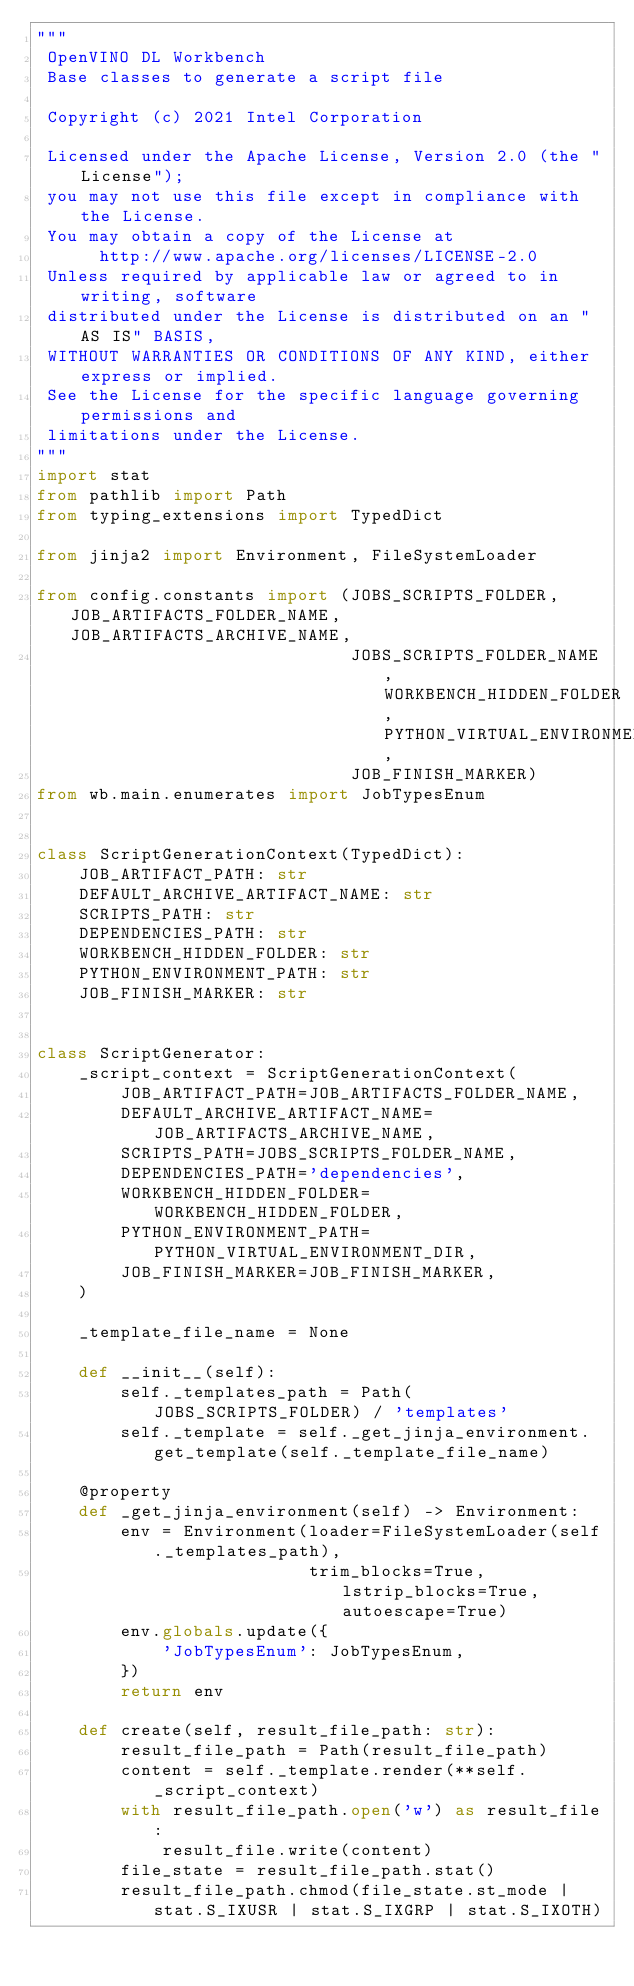<code> <loc_0><loc_0><loc_500><loc_500><_Python_>"""
 OpenVINO DL Workbench
 Base classes to generate a script file

 Copyright (c) 2021 Intel Corporation

 Licensed under the Apache License, Version 2.0 (the "License");
 you may not use this file except in compliance with the License.
 You may obtain a copy of the License at
      http://www.apache.org/licenses/LICENSE-2.0
 Unless required by applicable law or agreed to in writing, software
 distributed under the License is distributed on an "AS IS" BASIS,
 WITHOUT WARRANTIES OR CONDITIONS OF ANY KIND, either express or implied.
 See the License for the specific language governing permissions and
 limitations under the License.
"""
import stat
from pathlib import Path
from typing_extensions import TypedDict

from jinja2 import Environment, FileSystemLoader

from config.constants import (JOBS_SCRIPTS_FOLDER, JOB_ARTIFACTS_FOLDER_NAME, JOB_ARTIFACTS_ARCHIVE_NAME,
                              JOBS_SCRIPTS_FOLDER_NAME, WORKBENCH_HIDDEN_FOLDER, PYTHON_VIRTUAL_ENVIRONMENT_DIR,
                              JOB_FINISH_MARKER)
from wb.main.enumerates import JobTypesEnum


class ScriptGenerationContext(TypedDict):
    JOB_ARTIFACT_PATH: str
    DEFAULT_ARCHIVE_ARTIFACT_NAME: str
    SCRIPTS_PATH: str
    DEPENDENCIES_PATH: str
    WORKBENCH_HIDDEN_FOLDER: str
    PYTHON_ENVIRONMENT_PATH: str
    JOB_FINISH_MARKER: str


class ScriptGenerator:
    _script_context = ScriptGenerationContext(
        JOB_ARTIFACT_PATH=JOB_ARTIFACTS_FOLDER_NAME,
        DEFAULT_ARCHIVE_ARTIFACT_NAME=JOB_ARTIFACTS_ARCHIVE_NAME,
        SCRIPTS_PATH=JOBS_SCRIPTS_FOLDER_NAME,
        DEPENDENCIES_PATH='dependencies',
        WORKBENCH_HIDDEN_FOLDER=WORKBENCH_HIDDEN_FOLDER,
        PYTHON_ENVIRONMENT_PATH=PYTHON_VIRTUAL_ENVIRONMENT_DIR,
        JOB_FINISH_MARKER=JOB_FINISH_MARKER,
    )

    _template_file_name = None

    def __init__(self):
        self._templates_path = Path(JOBS_SCRIPTS_FOLDER) / 'templates'
        self._template = self._get_jinja_environment.get_template(self._template_file_name)

    @property
    def _get_jinja_environment(self) -> Environment:
        env = Environment(loader=FileSystemLoader(self._templates_path),
                          trim_blocks=True, lstrip_blocks=True, autoescape=True)
        env.globals.update({
            'JobTypesEnum': JobTypesEnum,
        })
        return env

    def create(self, result_file_path: str):
        result_file_path = Path(result_file_path)
        content = self._template.render(**self._script_context)
        with result_file_path.open('w') as result_file:
            result_file.write(content)
        file_state = result_file_path.stat()
        result_file_path.chmod(file_state.st_mode | stat.S_IXUSR | stat.S_IXGRP | stat.S_IXOTH)
</code> 